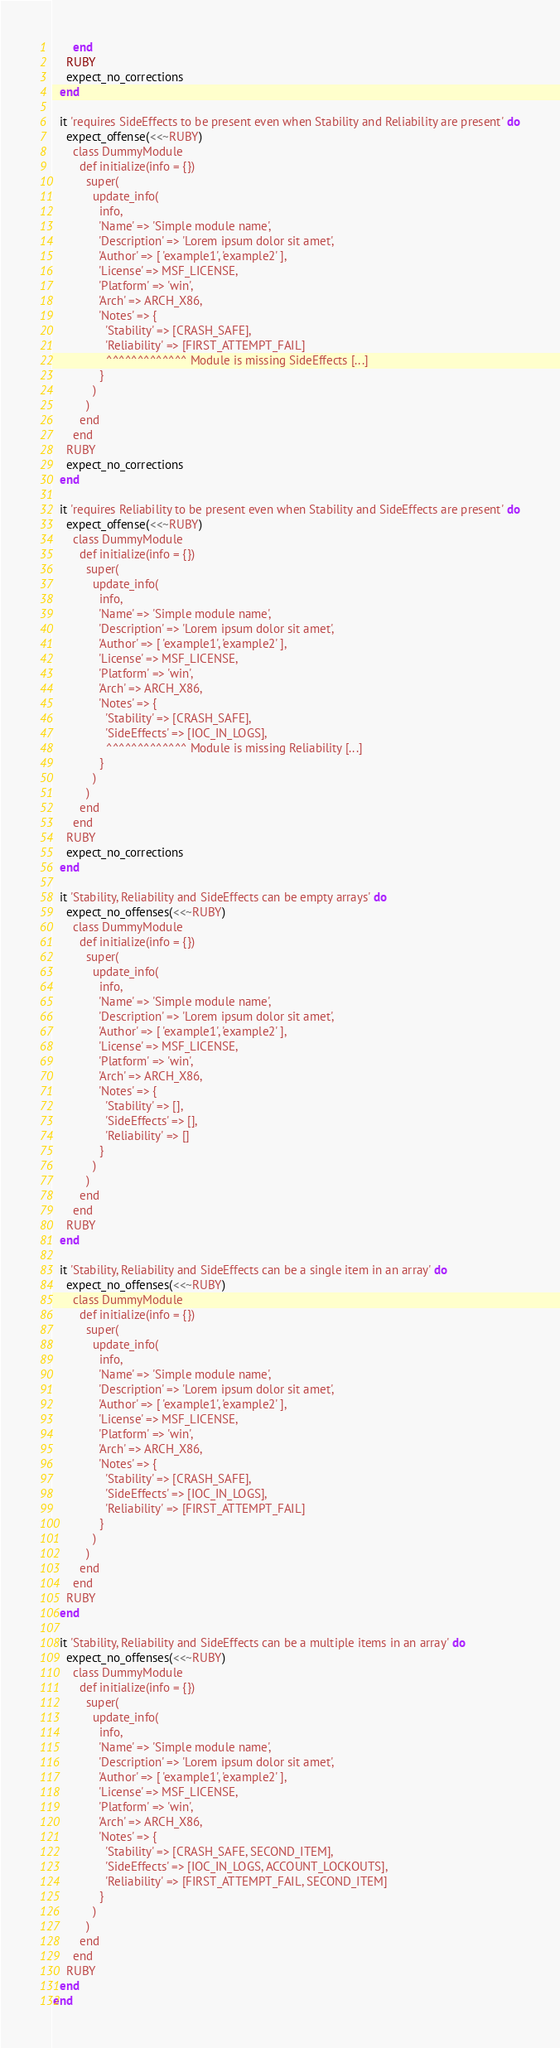Convert code to text. <code><loc_0><loc_0><loc_500><loc_500><_Ruby_>      end
    RUBY
    expect_no_corrections
  end

  it 'requires SideEffects to be present even when Stability and Reliability are present' do
    expect_offense(<<~RUBY)
      class DummyModule
        def initialize(info = {})
          super(
            update_info(
              info,
              'Name' => 'Simple module name',
              'Description' => 'Lorem ipsum dolor sit amet',
              'Author' => [ 'example1', 'example2' ],
              'License' => MSF_LICENSE,
              'Platform' => 'win',
              'Arch' => ARCH_X86,
              'Notes' => {
                'Stability' => [CRASH_SAFE],
                'Reliability' => [FIRST_ATTEMPT_FAIL]
                ^^^^^^^^^^^^^ Module is missing SideEffects [...]
              }
            )
          )
        end
      end
    RUBY
    expect_no_corrections
  end

  it 'requires Reliability to be present even when Stability and SideEffects are present' do
    expect_offense(<<~RUBY)
      class DummyModule
        def initialize(info = {})
          super(
            update_info(
              info,
              'Name' => 'Simple module name',
              'Description' => 'Lorem ipsum dolor sit amet',
              'Author' => [ 'example1', 'example2' ],
              'License' => MSF_LICENSE,
              'Platform' => 'win',
              'Arch' => ARCH_X86,
              'Notes' => {
                'Stability' => [CRASH_SAFE],
                'SideEffects' => [IOC_IN_LOGS],
                ^^^^^^^^^^^^^ Module is missing Reliability [...]
              }
            )
          )
        end
      end
    RUBY
    expect_no_corrections
  end

  it 'Stability, Reliability and SideEffects can be empty arrays' do
    expect_no_offenses(<<~RUBY)
      class DummyModule
        def initialize(info = {})
          super(
            update_info(
              info,
              'Name' => 'Simple module name',
              'Description' => 'Lorem ipsum dolor sit amet',
              'Author' => [ 'example1', 'example2' ],
              'License' => MSF_LICENSE,
              'Platform' => 'win',
              'Arch' => ARCH_X86,
              'Notes' => {
                'Stability' => [],
                'SideEffects' => [],
                'Reliability' => []
              }
            )
          )
        end
      end
    RUBY
  end

  it 'Stability, Reliability and SideEffects can be a single item in an array' do
    expect_no_offenses(<<~RUBY)
      class DummyModule
        def initialize(info = {})
          super(
            update_info(
              info,
              'Name' => 'Simple module name',
              'Description' => 'Lorem ipsum dolor sit amet',
              'Author' => [ 'example1', 'example2' ],
              'License' => MSF_LICENSE,
              'Platform' => 'win',
              'Arch' => ARCH_X86,
              'Notes' => {
                'Stability' => [CRASH_SAFE],
                'SideEffects' => [IOC_IN_LOGS],
                'Reliability' => [FIRST_ATTEMPT_FAIL]
              }
            )
          )
        end
      end
    RUBY
  end

  it 'Stability, Reliability and SideEffects can be a multiple items in an array' do
    expect_no_offenses(<<~RUBY)
      class DummyModule
        def initialize(info = {})
          super(
            update_info(
              info,
              'Name' => 'Simple module name',
              'Description' => 'Lorem ipsum dolor sit amet',
              'Author' => [ 'example1', 'example2' ],
              'License' => MSF_LICENSE,
              'Platform' => 'win',
              'Arch' => ARCH_X86,
              'Notes' => {
                'Stability' => [CRASH_SAFE, SECOND_ITEM],
                'SideEffects' => [IOC_IN_LOGS, ACCOUNT_LOCKOUTS],
                'Reliability' => [FIRST_ATTEMPT_FAIL, SECOND_ITEM]
              }
            )
          )
        end
      end
    RUBY
  end
end
</code> 